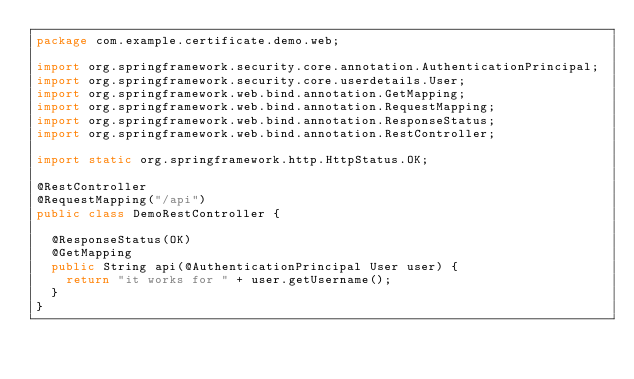<code> <loc_0><loc_0><loc_500><loc_500><_Java_>package com.example.certificate.demo.web;

import org.springframework.security.core.annotation.AuthenticationPrincipal;
import org.springframework.security.core.userdetails.User;
import org.springframework.web.bind.annotation.GetMapping;
import org.springframework.web.bind.annotation.RequestMapping;
import org.springframework.web.bind.annotation.ResponseStatus;
import org.springframework.web.bind.annotation.RestController;

import static org.springframework.http.HttpStatus.OK;

@RestController
@RequestMapping("/api")
public class DemoRestController {

  @ResponseStatus(OK)
  @GetMapping
  public String api(@AuthenticationPrincipal User user) {
    return "it works for " + user.getUsername();
  }
}
</code> 